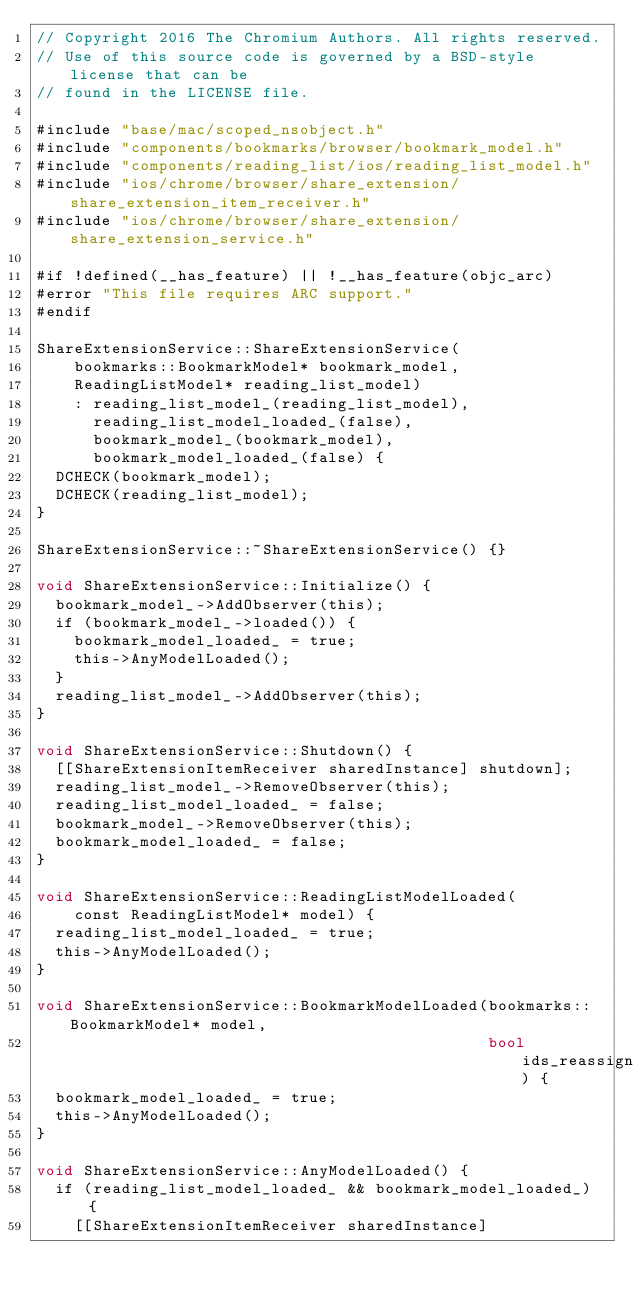<code> <loc_0><loc_0><loc_500><loc_500><_ObjectiveC_>// Copyright 2016 The Chromium Authors. All rights reserved.
// Use of this source code is governed by a BSD-style license that can be
// found in the LICENSE file.

#include "base/mac/scoped_nsobject.h"
#include "components/bookmarks/browser/bookmark_model.h"
#include "components/reading_list/ios/reading_list_model.h"
#include "ios/chrome/browser/share_extension/share_extension_item_receiver.h"
#include "ios/chrome/browser/share_extension/share_extension_service.h"

#if !defined(__has_feature) || !__has_feature(objc_arc)
#error "This file requires ARC support."
#endif

ShareExtensionService::ShareExtensionService(
    bookmarks::BookmarkModel* bookmark_model,
    ReadingListModel* reading_list_model)
    : reading_list_model_(reading_list_model),
      reading_list_model_loaded_(false),
      bookmark_model_(bookmark_model),
      bookmark_model_loaded_(false) {
  DCHECK(bookmark_model);
  DCHECK(reading_list_model);
}

ShareExtensionService::~ShareExtensionService() {}

void ShareExtensionService::Initialize() {
  bookmark_model_->AddObserver(this);
  if (bookmark_model_->loaded()) {
    bookmark_model_loaded_ = true;
    this->AnyModelLoaded();
  }
  reading_list_model_->AddObserver(this);
}

void ShareExtensionService::Shutdown() {
  [[ShareExtensionItemReceiver sharedInstance] shutdown];
  reading_list_model_->RemoveObserver(this);
  reading_list_model_loaded_ = false;
  bookmark_model_->RemoveObserver(this);
  bookmark_model_loaded_ = false;
}

void ShareExtensionService::ReadingListModelLoaded(
    const ReadingListModel* model) {
  reading_list_model_loaded_ = true;
  this->AnyModelLoaded();
}

void ShareExtensionService::BookmarkModelLoaded(bookmarks::BookmarkModel* model,
                                                bool ids_reassigned) {
  bookmark_model_loaded_ = true;
  this->AnyModelLoaded();
}

void ShareExtensionService::AnyModelLoaded() {
  if (reading_list_model_loaded_ && bookmark_model_loaded_) {
    [[ShareExtensionItemReceiver sharedInstance]</code> 